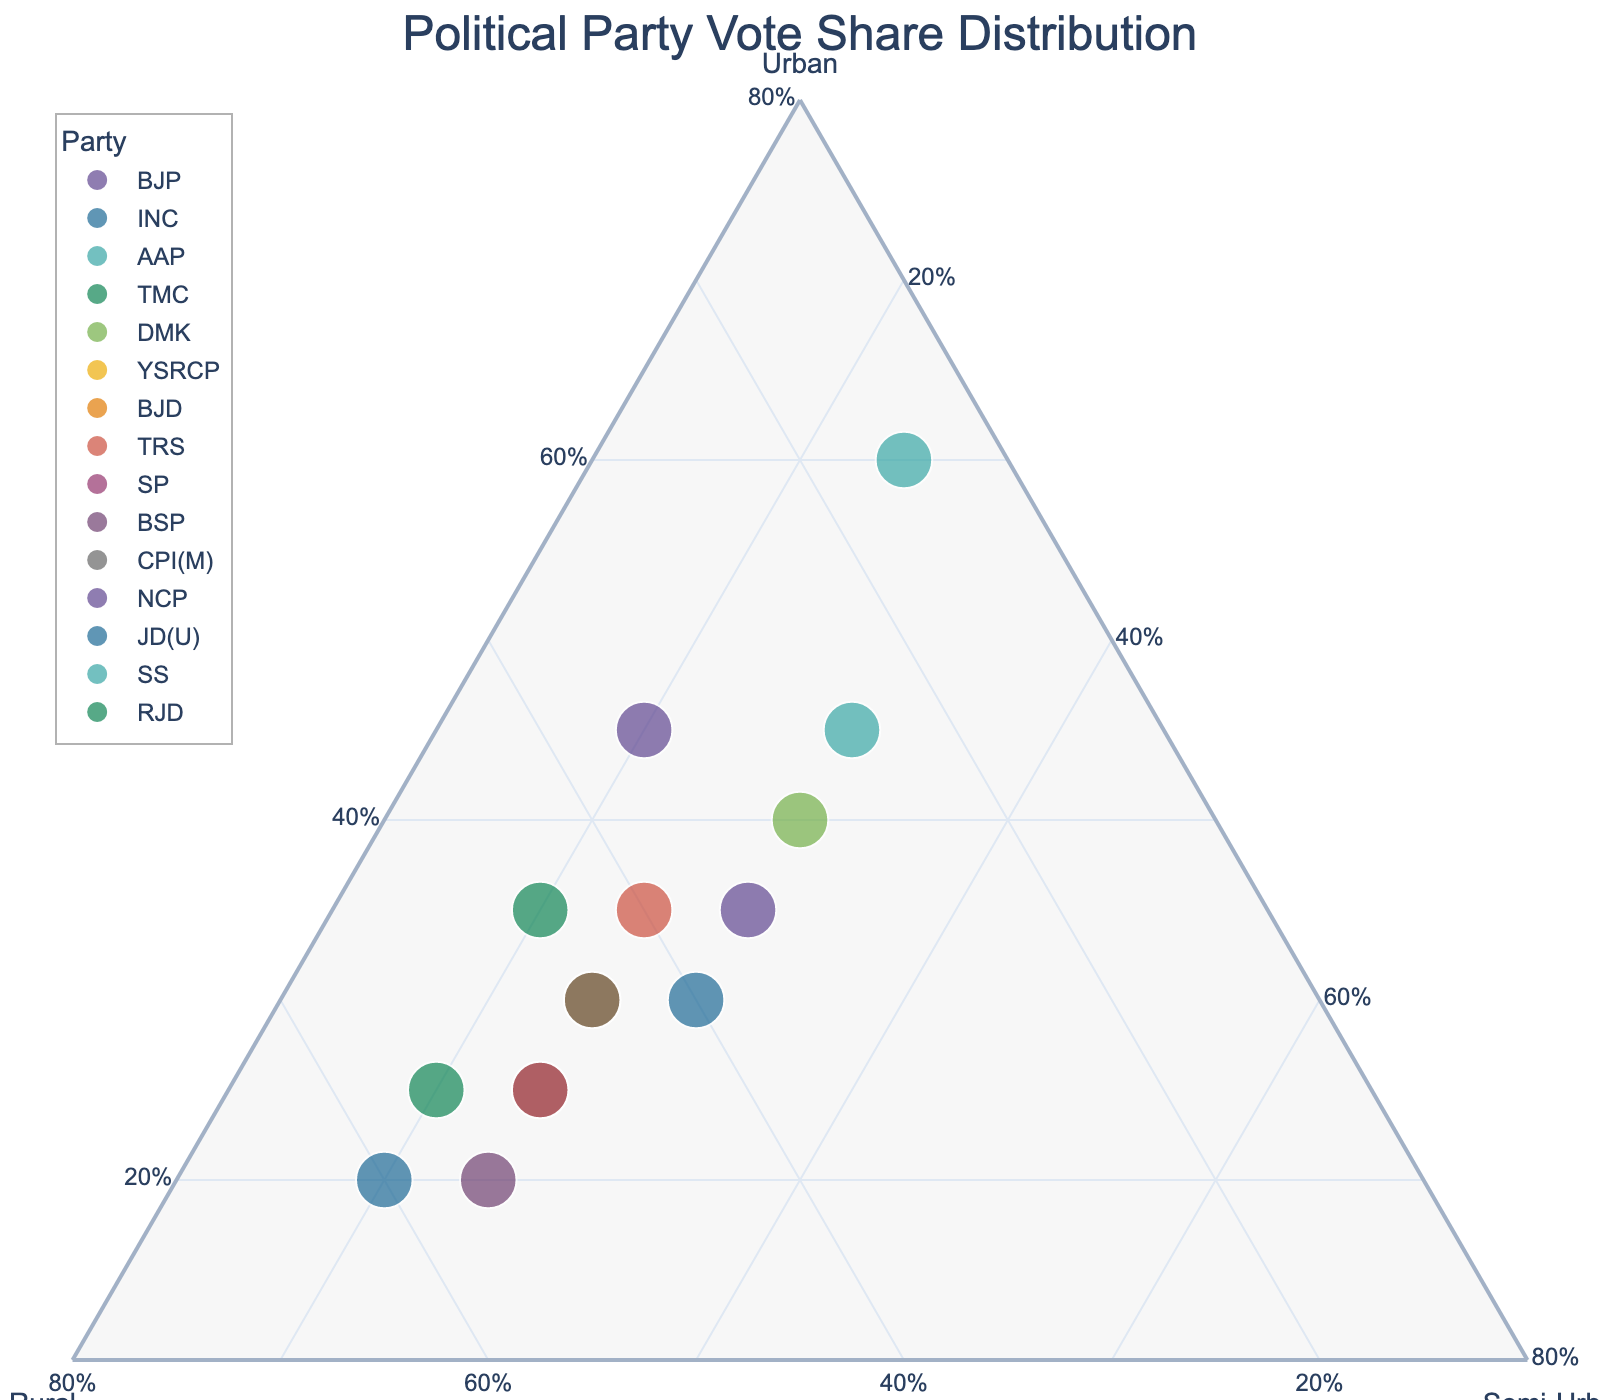What is the title of the plot? Look at the top center of the plot where the title is usually located. The title is "Political Party Vote Share Distribution".
Answer: Political Party Vote Share Distribution Which party has the highest vote share in urban areas? Find the point labeled with the party name and check its position on the Urban axis. The party at the top end of the Urban axis denotes the highest share. AAP is located highest on the Urban axis.
Answer: AAP What percentage of vote share does BJP have in rural areas? Locate BJP on the plot and look along the Rural axis. BJP's point is at 35% on the Rural axis.
Answer: 35% How much higher is AAP's vote share in urban areas compared to rural areas? Check AAP's positions on both the Urban and Rural axes, then calculate the difference. AAP's Urban share is 60% and Rural share is 15%, so the difference is 60% - 15% = 45%.
Answer: 45% Which party has an equal vote share in rural and semi-urban areas? Find the party whose point lies equally between Rural and Semi-Urban. YSRCP shows equal values of 25% in both rural and semi-urban areas.
Answer: YSRCP Arrange the following parties by ascending order of their vote share in semi-urban areas: BJP, INC, SP Find their positions on the Semi-Urban axis, then arrange 20% (BJP), 25% (SP), and 30% (INC).
Answer: BJP, SP, INC What is the range (difference between maximum and minimum) of vote shares in rural areas? Locate the maximum (JD(U) with 60%) and the minimum (AAP with 15%) points on the Rural axis and compute the difference. 60% - 15% = 45%.
Answer: 45% Which party’s vote share is closest to having an equal distribution among urban, rural, and semi-urban areas? Identify the point near the center of the ternary plot indicating equal distribution. NCP votes are closest to equally distributed with 35% (Urban), 35% (Rural), and 30% (Semi-Urban).
Answer: NCP Between BJP and SS, which party has a higher share in semi-urban areas? Compare the positions of BJP and SS on the Semi-Urban axis. SS holds 30%, and BJP holds 20%.
Answer: SS Which party has the highest overall involvement (sum of all regions' share)? Add the percentages for each party to find the highest total. AAP: 60 + 15 + 25 = 100; INC: 30 + 40 + 30 = 100; Etc. Since multiple parties (e.g., AAP and INC) sum up to 100%, multiple answers can be valid.
Answer: AAP, INC, etc 